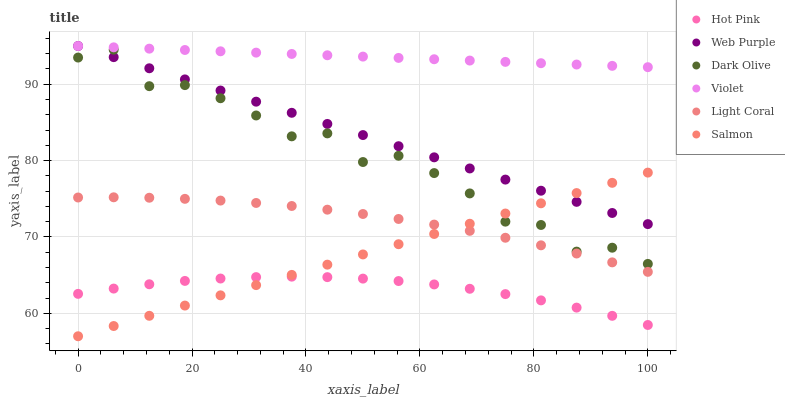Does Hot Pink have the minimum area under the curve?
Answer yes or no. Yes. Does Violet have the maximum area under the curve?
Answer yes or no. Yes. Does Dark Olive have the minimum area under the curve?
Answer yes or no. No. Does Dark Olive have the maximum area under the curve?
Answer yes or no. No. Is Violet the smoothest?
Answer yes or no. Yes. Is Dark Olive the roughest?
Answer yes or no. Yes. Is Salmon the smoothest?
Answer yes or no. No. Is Salmon the roughest?
Answer yes or no. No. Does Salmon have the lowest value?
Answer yes or no. Yes. Does Dark Olive have the lowest value?
Answer yes or no. No. Does Violet have the highest value?
Answer yes or no. Yes. Does Dark Olive have the highest value?
Answer yes or no. No. Is Light Coral less than Violet?
Answer yes or no. Yes. Is Violet greater than Hot Pink?
Answer yes or no. Yes. Does Hot Pink intersect Salmon?
Answer yes or no. Yes. Is Hot Pink less than Salmon?
Answer yes or no. No. Is Hot Pink greater than Salmon?
Answer yes or no. No. Does Light Coral intersect Violet?
Answer yes or no. No. 